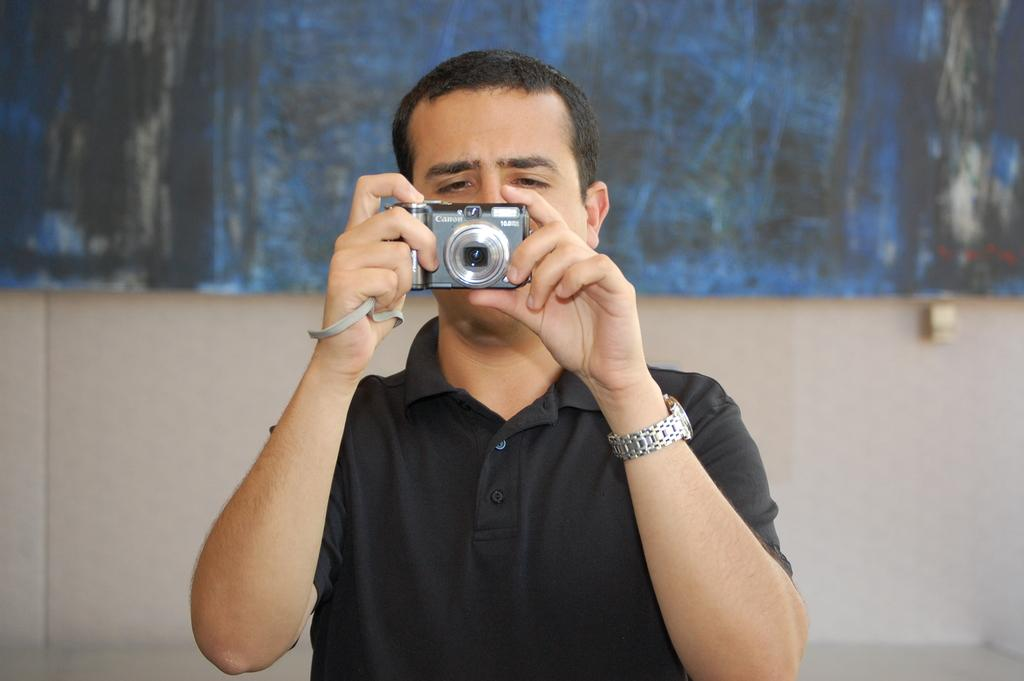What is present in the image? There is a man in the image. What is the man doing in the image? The man is standing in the image. What object is the man holding in the image? The man is holding a camera in the image. What type of fiction is the man reading in the image? There is no book or any indication of reading in the image; the man is holding a camera. Can you tell me how many robins are visible in the image? There are no robins present in the image. 